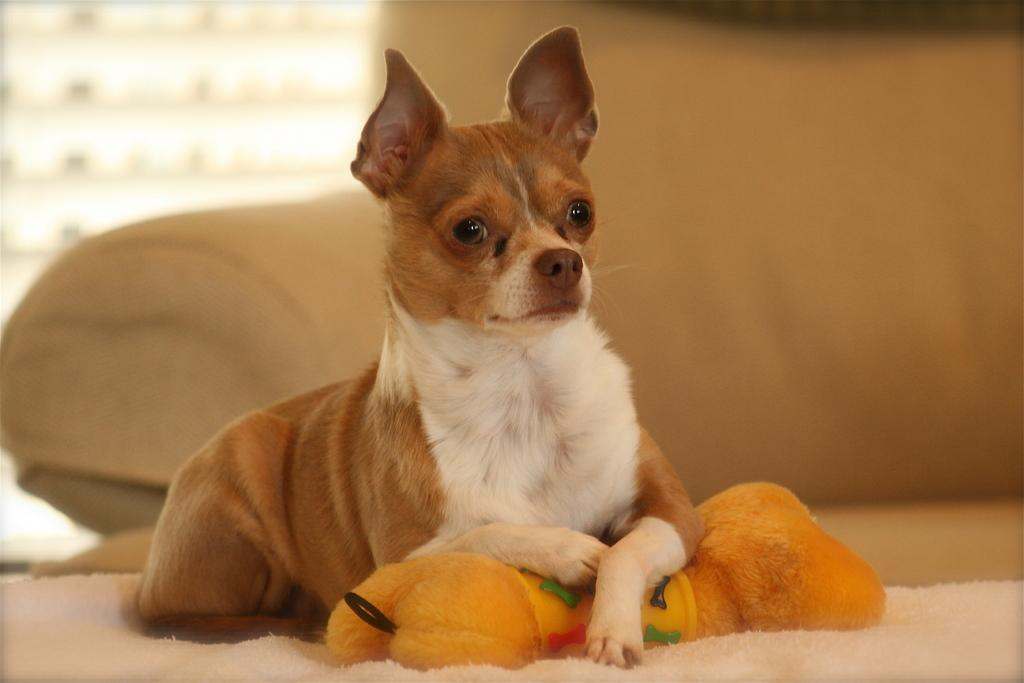What animal can be seen in the image? There is a dog in the image. What is the dog sitting on? The dog is sitting on a cloth. What type of furniture is visible in the background of the image? There is a sofa in the background of the image. How would you describe the background of the image? The background is blurry. What is the dog's reaction to the minister's speech in the image? There is no minister or speech present in the image, so it is not possible to determine the dog's reaction. 